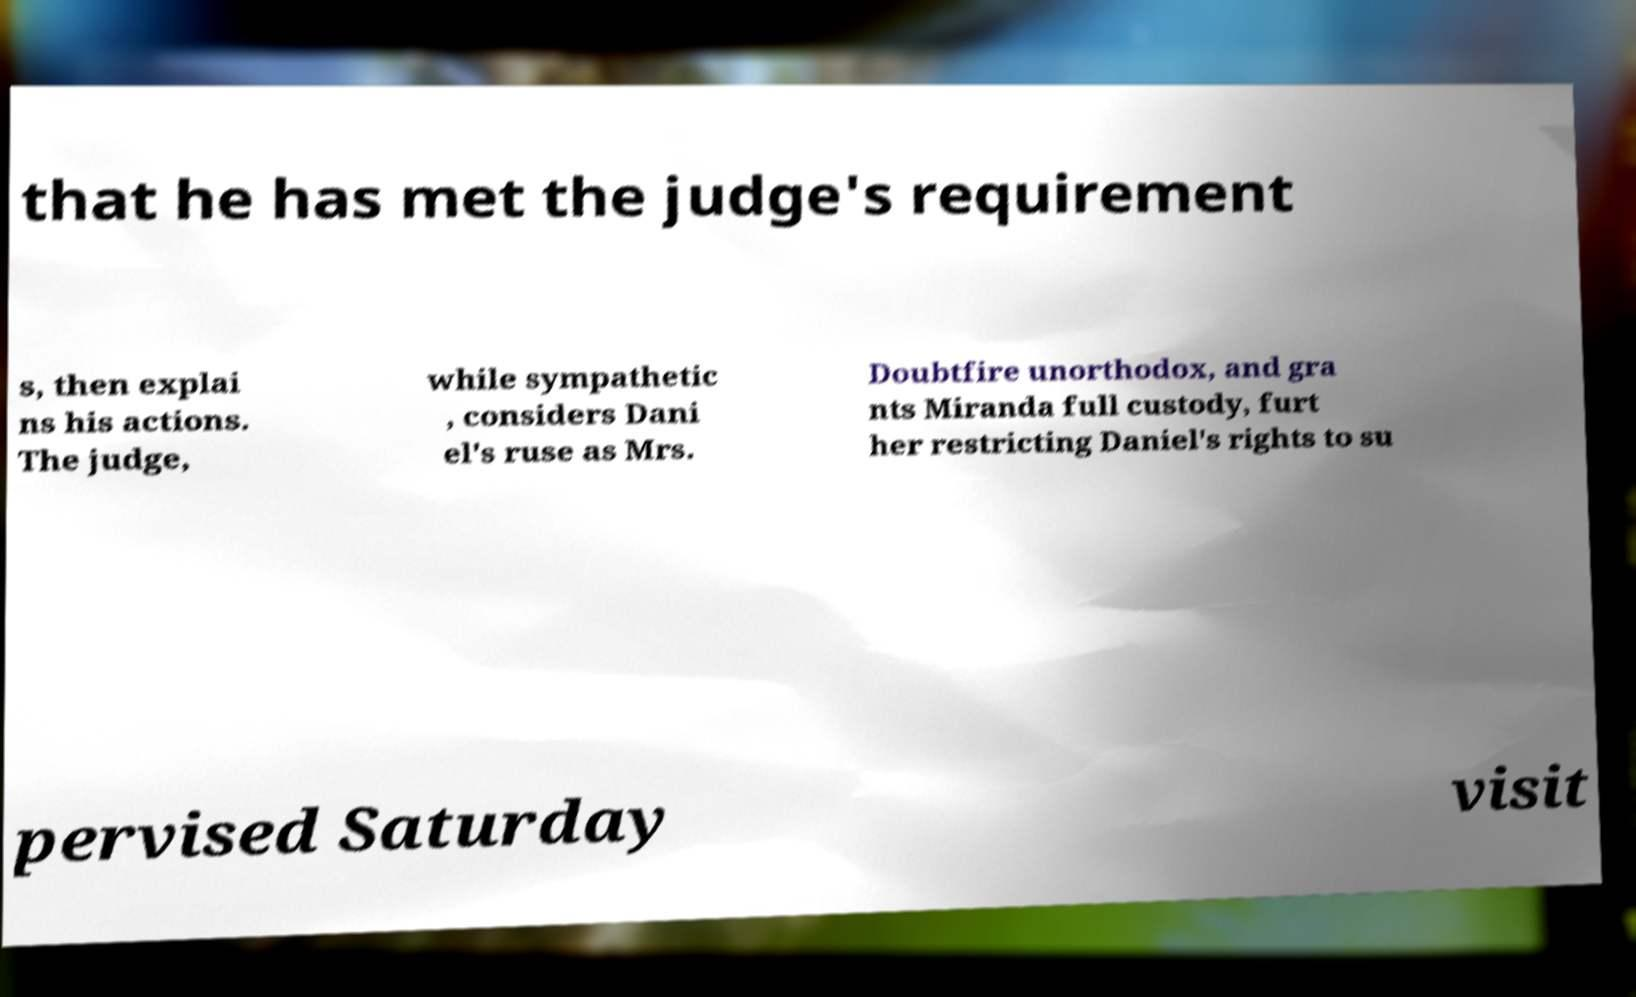Can you read and provide the text displayed in the image?This photo seems to have some interesting text. Can you extract and type it out for me? that he has met the judge's requirement s, then explai ns his actions. The judge, while sympathetic , considers Dani el's ruse as Mrs. Doubtfire unorthodox, and gra nts Miranda full custody, furt her restricting Daniel's rights to su pervised Saturday visit 